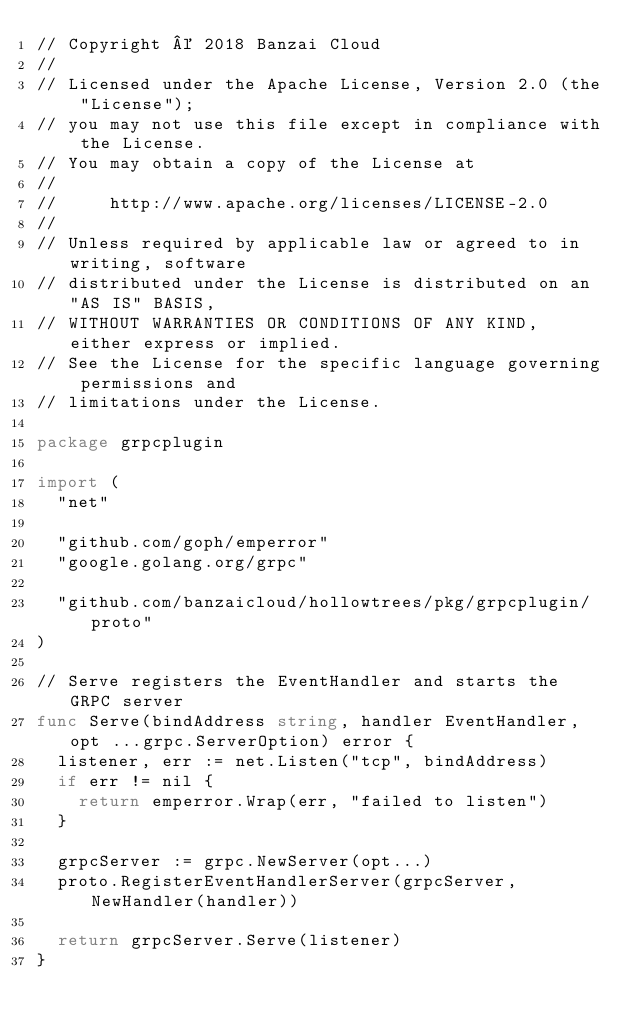<code> <loc_0><loc_0><loc_500><loc_500><_Go_>// Copyright © 2018 Banzai Cloud
//
// Licensed under the Apache License, Version 2.0 (the "License");
// you may not use this file except in compliance with the License.
// You may obtain a copy of the License at
//
//     http://www.apache.org/licenses/LICENSE-2.0
//
// Unless required by applicable law or agreed to in writing, software
// distributed under the License is distributed on an "AS IS" BASIS,
// WITHOUT WARRANTIES OR CONDITIONS OF ANY KIND, either express or implied.
// See the License for the specific language governing permissions and
// limitations under the License.

package grpcplugin

import (
	"net"

	"github.com/goph/emperror"
	"google.golang.org/grpc"

	"github.com/banzaicloud/hollowtrees/pkg/grpcplugin/proto"
)

// Serve registers the EventHandler and starts the GRPC server
func Serve(bindAddress string, handler EventHandler, opt ...grpc.ServerOption) error {
	listener, err := net.Listen("tcp", bindAddress)
	if err != nil {
		return emperror.Wrap(err, "failed to listen")
	}

	grpcServer := grpc.NewServer(opt...)
	proto.RegisterEventHandlerServer(grpcServer, NewHandler(handler))

	return grpcServer.Serve(listener)
}
</code> 